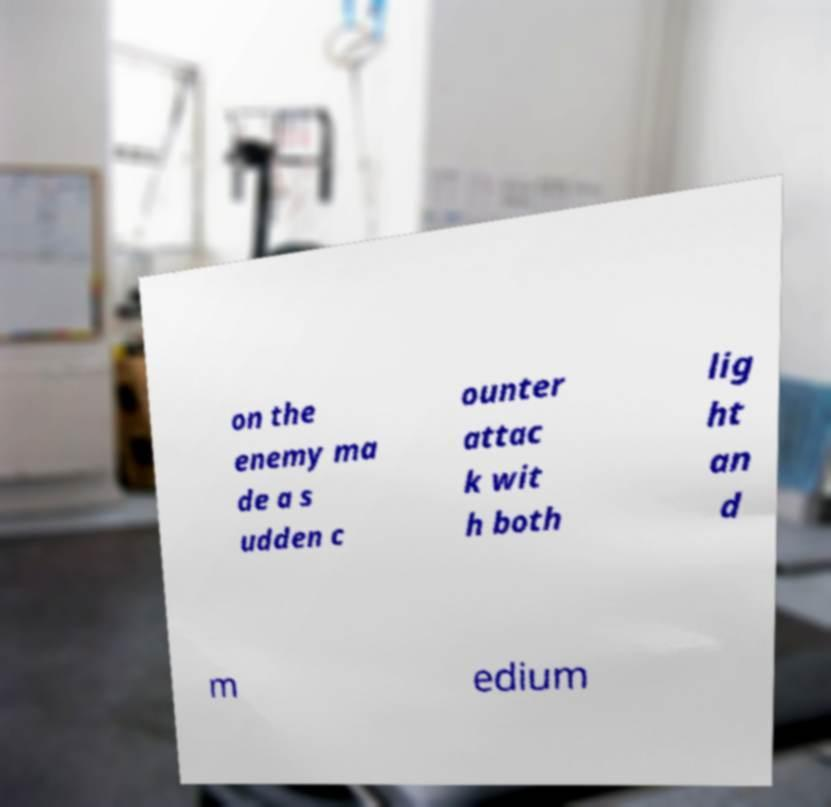What messages or text are displayed in this image? I need them in a readable, typed format. on the enemy ma de a s udden c ounter attac k wit h both lig ht an d m edium 